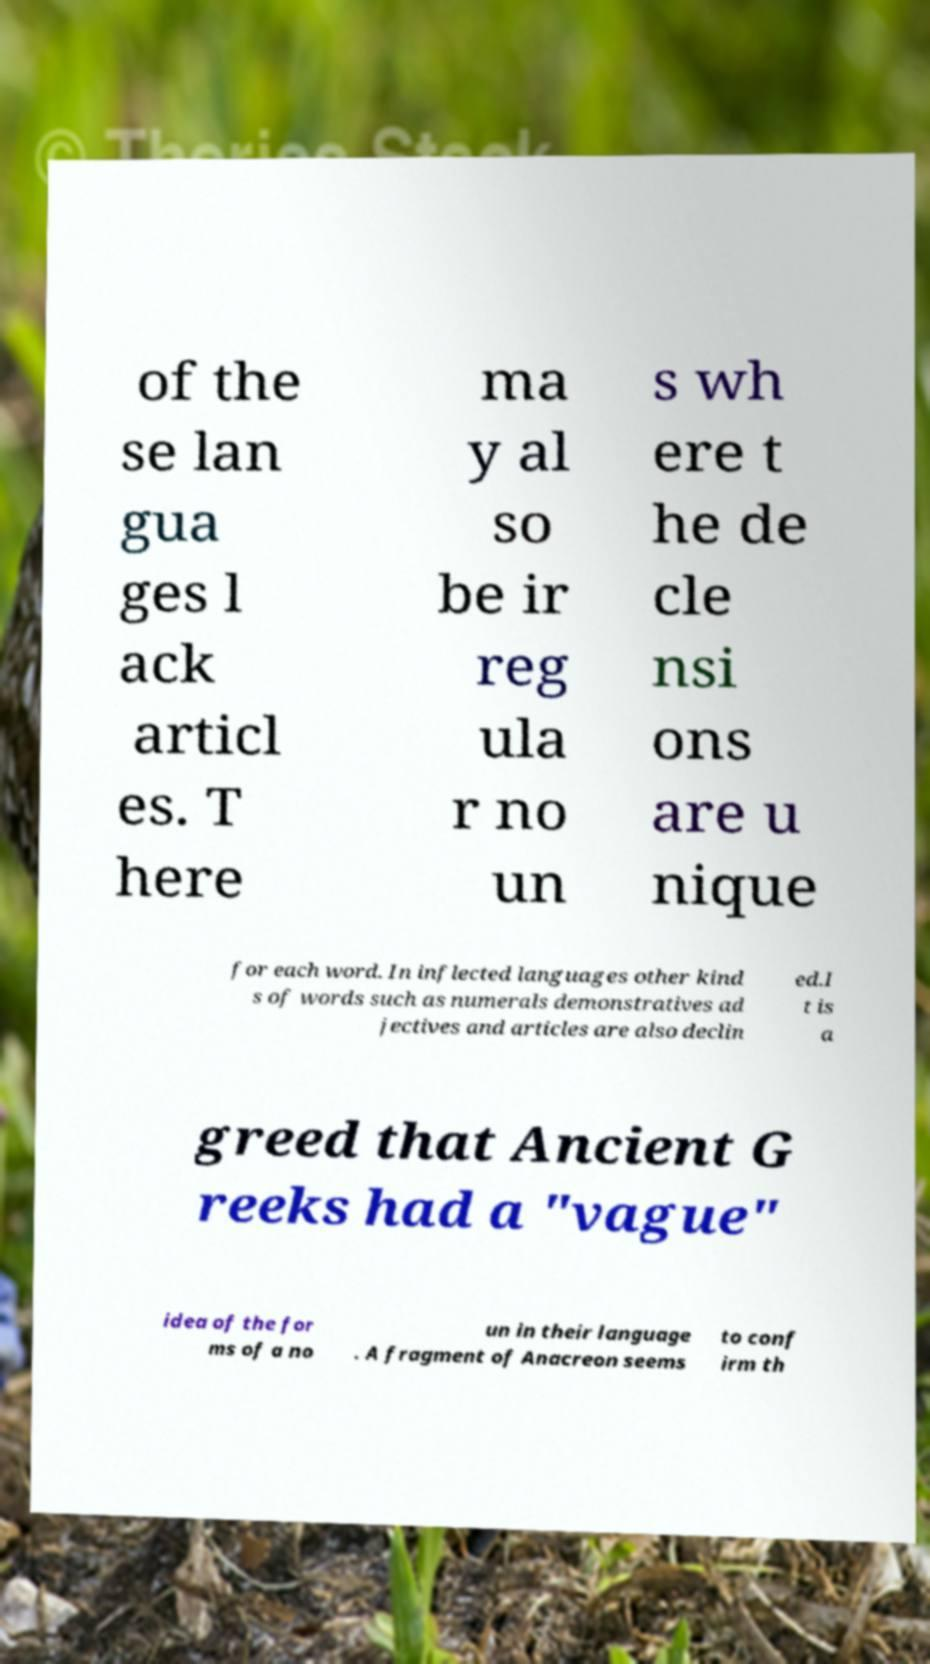Can you read and provide the text displayed in the image?This photo seems to have some interesting text. Can you extract and type it out for me? of the se lan gua ges l ack articl es. T here ma y al so be ir reg ula r no un s wh ere t he de cle nsi ons are u nique for each word. In inflected languages other kind s of words such as numerals demonstratives ad jectives and articles are also declin ed.I t is a greed that Ancient G reeks had a "vague" idea of the for ms of a no un in their language . A fragment of Anacreon seems to conf irm th 